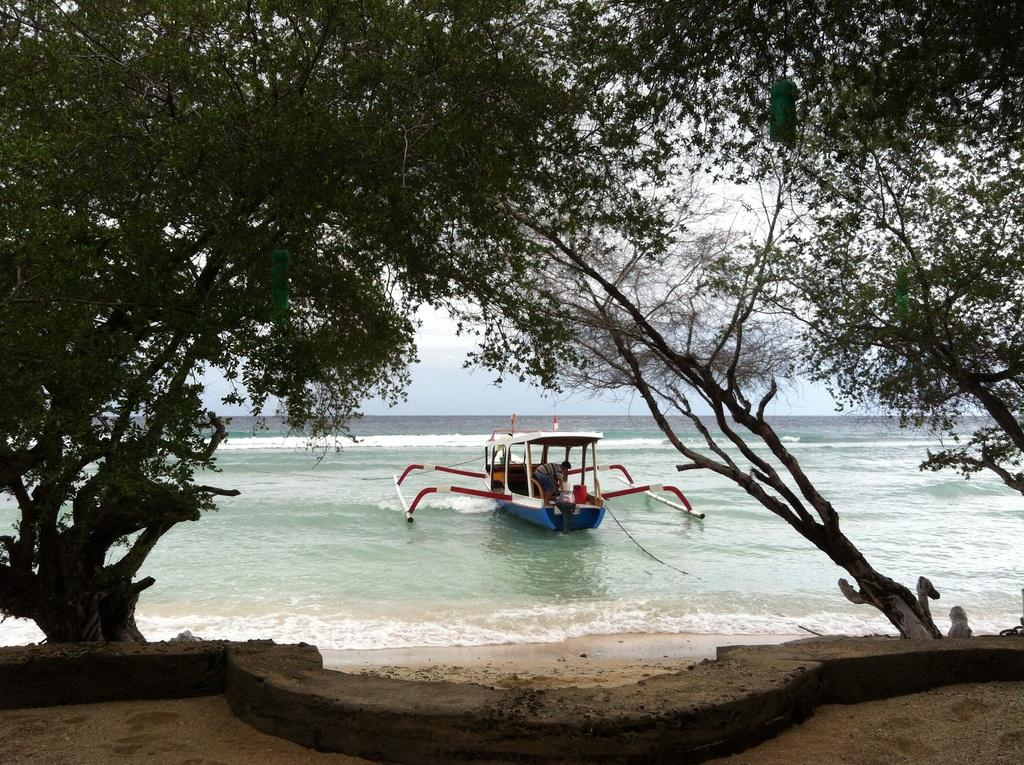What is the person doing in the image? The person is inside a boat in the image. Where is the boat located? The boat is in the water. What is the boat's destination in the image? The boat is arriving at the seashore. What can be seen in the background of the image? There are trees visible in the image. What color is the daughter's shirt in the image? There is no daughter present in the image, so it is not possible to answer that question. 